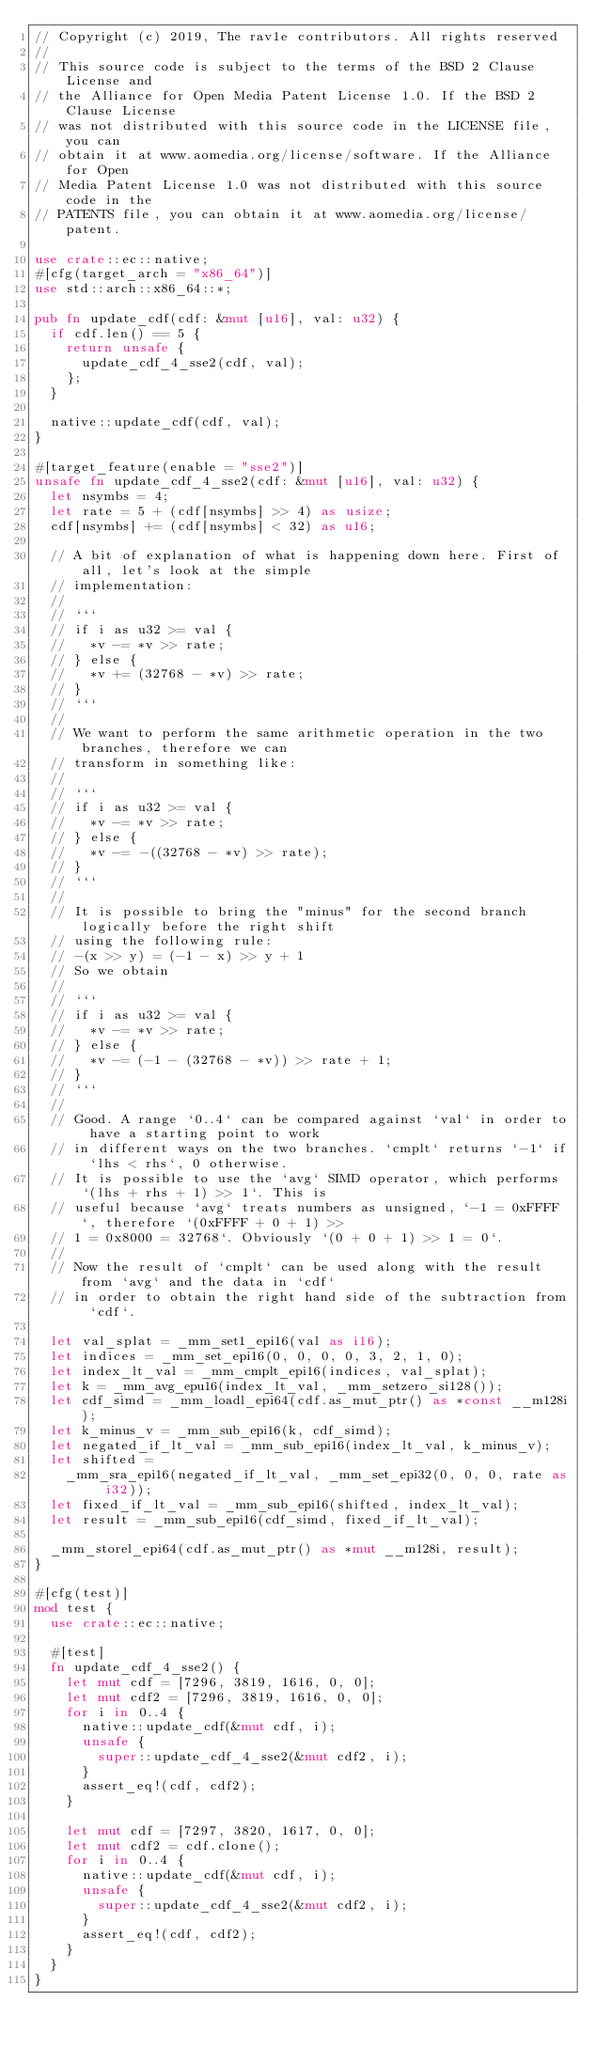Convert code to text. <code><loc_0><loc_0><loc_500><loc_500><_Rust_>// Copyright (c) 2019, The rav1e contributors. All rights reserved
//
// This source code is subject to the terms of the BSD 2 Clause License and
// the Alliance for Open Media Patent License 1.0. If the BSD 2 Clause License
// was not distributed with this source code in the LICENSE file, you can
// obtain it at www.aomedia.org/license/software. If the Alliance for Open
// Media Patent License 1.0 was not distributed with this source code in the
// PATENTS file, you can obtain it at www.aomedia.org/license/patent.

use crate::ec::native;
#[cfg(target_arch = "x86_64")]
use std::arch::x86_64::*;

pub fn update_cdf(cdf: &mut [u16], val: u32) {
  if cdf.len() == 5 {
    return unsafe {
      update_cdf_4_sse2(cdf, val);
    };
  }

  native::update_cdf(cdf, val);
}

#[target_feature(enable = "sse2")]
unsafe fn update_cdf_4_sse2(cdf: &mut [u16], val: u32) {
  let nsymbs = 4;
  let rate = 5 + (cdf[nsymbs] >> 4) as usize;
  cdf[nsymbs] += (cdf[nsymbs] < 32) as u16;

  // A bit of explanation of what is happening down here. First of all, let's look at the simple
  // implementation:
  //
  // ```
  // if i as u32 >= val {
  //   *v -= *v >> rate;
  // } else {
  //   *v += (32768 - *v) >> rate;
  // }
  // ```
  //
  // We want to perform the same arithmetic operation in the two branches, therefore we can
  // transform in something like:
  //
  // ```
  // if i as u32 >= val {
  //   *v -= *v >> rate;
  // } else {
  //   *v -= -((32768 - *v) >> rate);
  // }
  // ```
  //
  // It is possible to bring the "minus" for the second branch logically before the right shift
  // using the following rule:
  // -(x >> y) = (-1 - x) >> y + 1
  // So we obtain
  //
  // ```
  // if i as u32 >= val {
  //   *v -= *v >> rate;
  // } else {
  //   *v -= (-1 - (32768 - *v)) >> rate + 1;
  // }
  // ```
  //
  // Good. A range `0..4` can be compared against `val` in order to have a starting point to work
  // in different ways on the two branches. `cmplt` returns `-1` if `lhs < rhs`, 0 otherwise.
  // It is possible to use the `avg` SIMD operator, which performs `(lhs + rhs + 1) >> 1`. This is
  // useful because `avg` treats numbers as unsigned, `-1 = 0xFFFF`, therefore `(0xFFFF + 0 + 1) >>
  // 1 = 0x8000 = 32768`. Obviously `(0 + 0 + 1) >> 1 = 0`.
  //
  // Now the result of `cmplt` can be used along with the result from `avg` and the data in `cdf`
  // in order to obtain the right hand side of the subtraction from `cdf`.

  let val_splat = _mm_set1_epi16(val as i16);
  let indices = _mm_set_epi16(0, 0, 0, 0, 3, 2, 1, 0);
  let index_lt_val = _mm_cmplt_epi16(indices, val_splat);
  let k = _mm_avg_epu16(index_lt_val, _mm_setzero_si128());
  let cdf_simd = _mm_loadl_epi64(cdf.as_mut_ptr() as *const __m128i);
  let k_minus_v = _mm_sub_epi16(k, cdf_simd);
  let negated_if_lt_val = _mm_sub_epi16(index_lt_val, k_minus_v);
  let shifted =
    _mm_sra_epi16(negated_if_lt_val, _mm_set_epi32(0, 0, 0, rate as i32));
  let fixed_if_lt_val = _mm_sub_epi16(shifted, index_lt_val);
  let result = _mm_sub_epi16(cdf_simd, fixed_if_lt_val);

  _mm_storel_epi64(cdf.as_mut_ptr() as *mut __m128i, result);
}

#[cfg(test)]
mod test {
  use crate::ec::native;

  #[test]
  fn update_cdf_4_sse2() {
    let mut cdf = [7296, 3819, 1616, 0, 0];
    let mut cdf2 = [7296, 3819, 1616, 0, 0];
    for i in 0..4 {
      native::update_cdf(&mut cdf, i);
      unsafe {
        super::update_cdf_4_sse2(&mut cdf2, i);
      }
      assert_eq!(cdf, cdf2);
    }

    let mut cdf = [7297, 3820, 1617, 0, 0];
    let mut cdf2 = cdf.clone();
    for i in 0..4 {
      native::update_cdf(&mut cdf, i);
      unsafe {
        super::update_cdf_4_sse2(&mut cdf2, i);
      }
      assert_eq!(cdf, cdf2);
    }
  }
}
</code> 